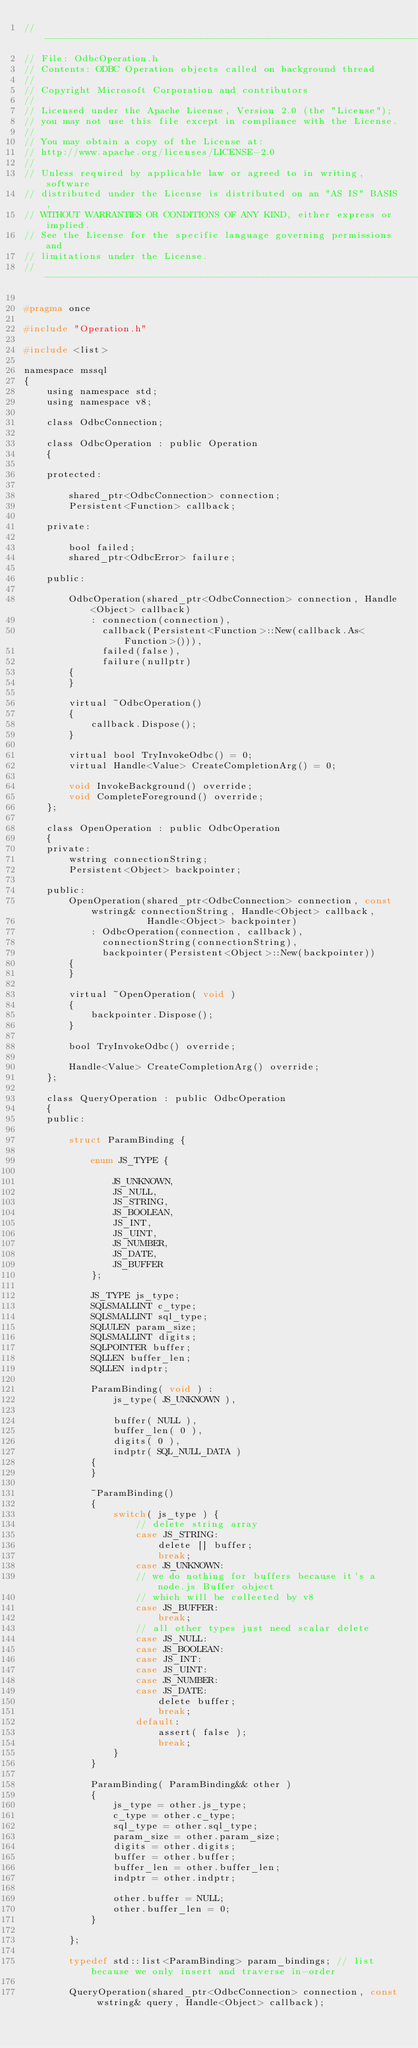Convert code to text. <code><loc_0><loc_0><loc_500><loc_500><_C_>//---------------------------------------------------------------------------------------------------------------------------------
// File: OdbcOperation.h
// Contents: ODBC Operation objects called on background thread
// 
// Copyright Microsoft Corporation and contributors
//
// Licensed under the Apache License, Version 2.0 (the "License");
// you may not use this file except in compliance with the License.
//
// You may obtain a copy of the License at:
// http://www.apache.org/licenses/LICENSE-2.0
//
// Unless required by applicable law or agreed to in writing, software
// distributed under the License is distributed on an "AS IS" BASIS,
// WITHOUT WARRANTIES OR CONDITIONS OF ANY KIND, either express or implied.
// See the License for the specific language governing permissions and
// limitations under the License.
//---------------------------------------------------------------------------------------------------------------------------------

#pragma once

#include "Operation.h"

#include <list>

namespace mssql
{
    using namespace std;
    using namespace v8;

    class OdbcConnection;

    class OdbcOperation : public Operation
    {

    protected:

        shared_ptr<OdbcConnection> connection;
        Persistent<Function> callback;

    private:

        bool failed;
        shared_ptr<OdbcError> failure;

    public:

        OdbcOperation(shared_ptr<OdbcConnection> connection, Handle<Object> callback)
            : connection(connection), 
              callback(Persistent<Function>::New(callback.As<Function>())),
              failed(false),
              failure(nullptr)
        {
        }

        virtual ~OdbcOperation()
        {
            callback.Dispose();
        }
 
        virtual bool TryInvokeOdbc() = 0;
        virtual Handle<Value> CreateCompletionArg() = 0;

        void InvokeBackground() override;
        void CompleteForeground() override;
    };

    class OpenOperation : public OdbcOperation
    {
    private:
        wstring connectionString;
        Persistent<Object> backpointer;

    public:
        OpenOperation(shared_ptr<OdbcConnection> connection, const wstring& connectionString, Handle<Object> callback, 
                      Handle<Object> backpointer)
            : OdbcOperation(connection, callback), 
              connectionString(connectionString), 
              backpointer(Persistent<Object>::New(backpointer))
        {
        }

        virtual ~OpenOperation( void )
        {
            backpointer.Dispose();
        }

        bool TryInvokeOdbc() override;

        Handle<Value> CreateCompletionArg() override;
    };
    
    class QueryOperation : public OdbcOperation
    {
    public:

        struct ParamBinding {

            enum JS_TYPE {

                JS_UNKNOWN,
                JS_NULL,
                JS_STRING,
                JS_BOOLEAN,
                JS_INT,
                JS_UINT,
                JS_NUMBER,
                JS_DATE,
                JS_BUFFER
            };

            JS_TYPE js_type;
            SQLSMALLINT c_type;
            SQLSMALLINT sql_type;
            SQLULEN param_size;
            SQLSMALLINT digits;
            SQLPOINTER buffer;
            SQLLEN buffer_len;
            SQLLEN indptr;

            ParamBinding( void ) :
                js_type( JS_UNKNOWN ),

                buffer( NULL ),
                buffer_len( 0 ),
                digits( 0 ),
                indptr( SQL_NULL_DATA )
            {
            }

            ~ParamBinding()
            {
                switch( js_type ) {
                    // delete string array
                    case JS_STRING:
                        delete [] buffer;
                        break;
                    case JS_UNKNOWN:
                    // we do nothing for buffers because it's a node.js Buffer object
                    // which will be collected by v8
                    case JS_BUFFER:
                        break;
                    // all other types just need scalar delete
                    case JS_NULL:
                    case JS_BOOLEAN:
                    case JS_INT:
                    case JS_UINT:
                    case JS_NUMBER:
                    case JS_DATE:
                        delete buffer;
                        break;
                    default:
                        assert( false );
                        break;
                }
            }

            ParamBinding( ParamBinding&& other )
            {
                js_type = other.js_type;
                c_type = other.c_type;
                sql_type = other.sql_type;
                param_size = other.param_size;
                digits = other.digits;
                buffer = other.buffer;
                buffer_len = other.buffer_len;
                indptr = other.indptr;

                other.buffer = NULL;
                other.buffer_len = 0;
            }

        };

        typedef std::list<ParamBinding> param_bindings; // list because we only insert and traverse in-order

        QueryOperation(shared_ptr<OdbcConnection> connection, const wstring& query, Handle<Object> callback);
</code> 